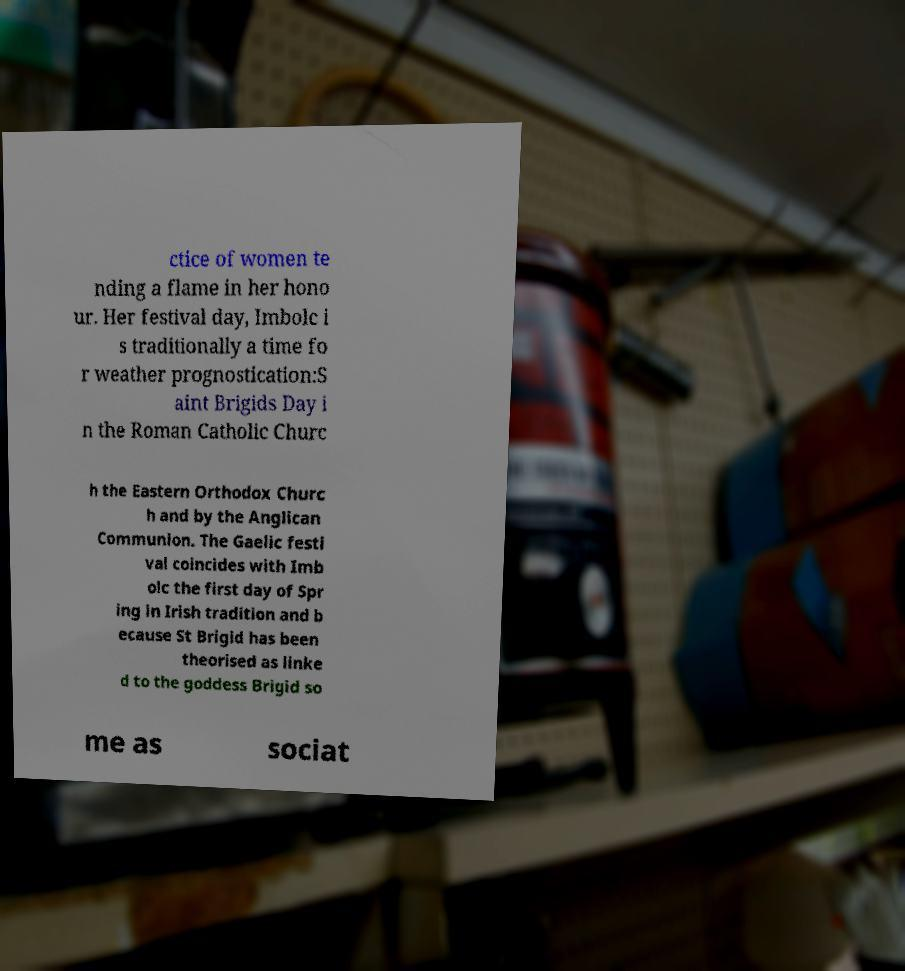Please read and relay the text visible in this image. What does it say? ctice of women te nding a flame in her hono ur. Her festival day, Imbolc i s traditionally a time fo r weather prognostication:S aint Brigids Day i n the Roman Catholic Churc h the Eastern Orthodox Churc h and by the Anglican Communion. The Gaelic festi val coincides with Imb olc the first day of Spr ing in Irish tradition and b ecause St Brigid has been theorised as linke d to the goddess Brigid so me as sociat 